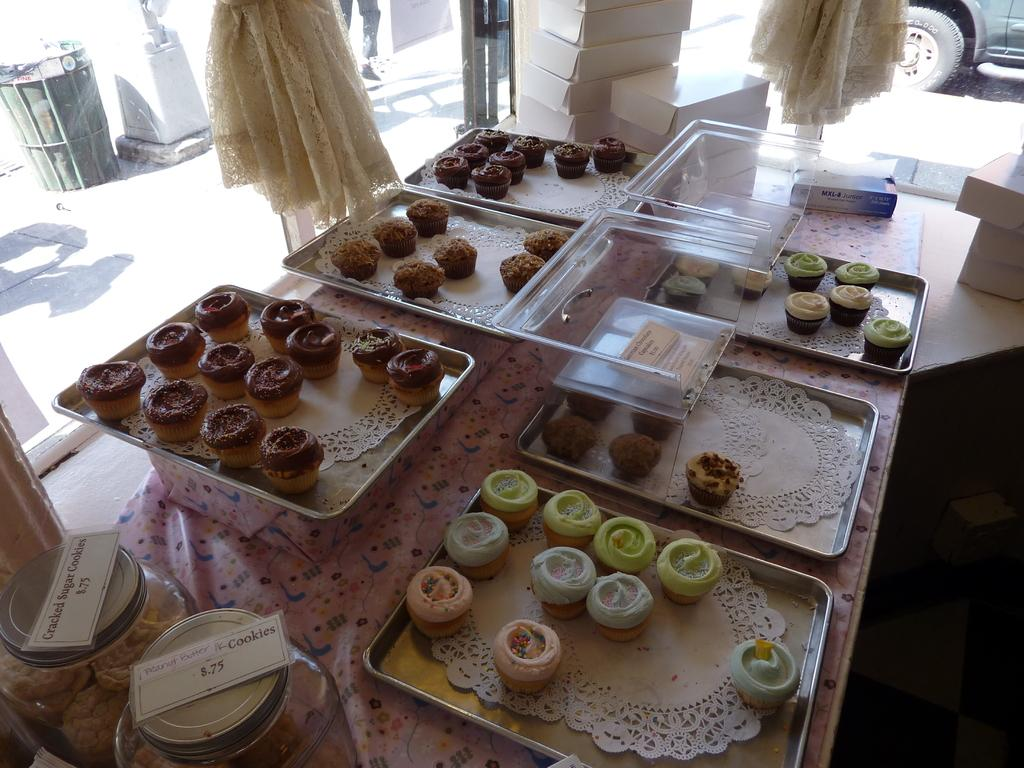What type of food is displayed on trays in the image? There are cupcakes on trays in the image. How are the cookies stored in the image? The cookies are stored in glass containers in the image. What type of window treatment is visible in the image? There are curtains visible in the image. How many windows can be seen in the image? There are windows in the image. What type of vehicle is present in the image? A vehicle is present in the image. Where is the trash bin located in the image? The trash bin is at the top side of the image. What type of activity is taking place on the stove in the image? There is no stove present in the image, so no activity can be observed on a stove. 